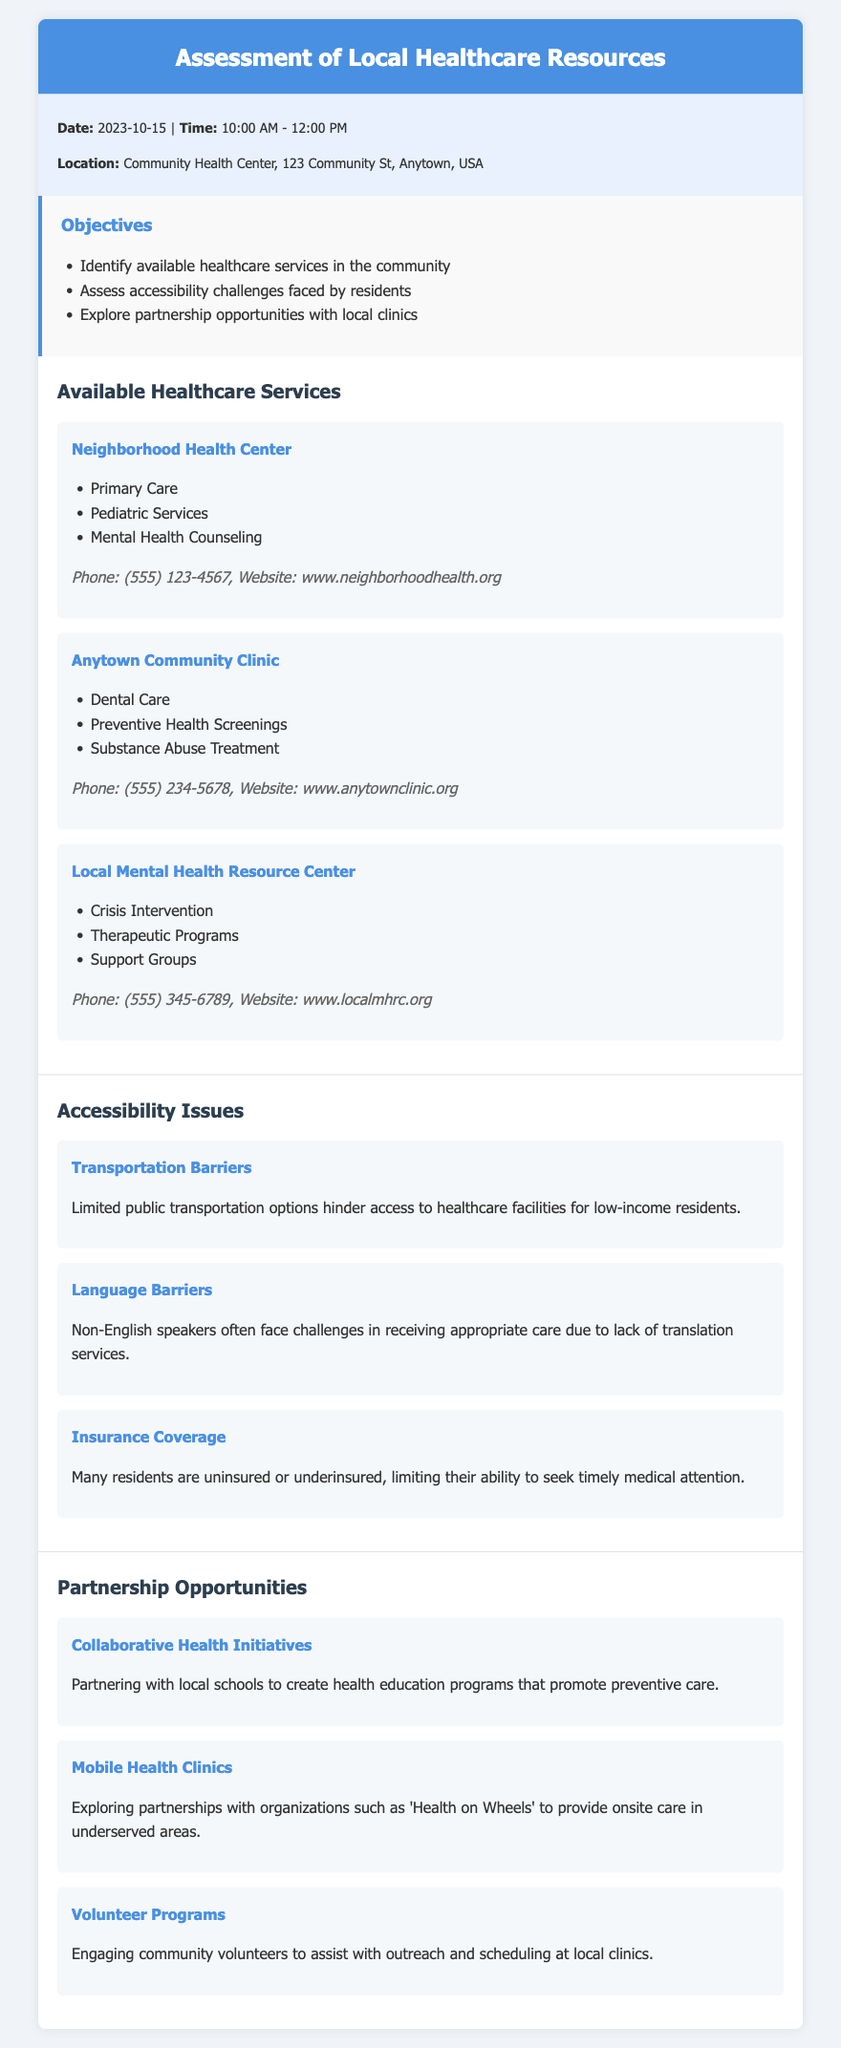What is the date of the assessment? The date of the assessment is mentioned in the meta-info section of the document.
Answer: 2023-10-15 What service does the Neighborhood Health Center provide? The document lists the services provided by the Neighborhood Health Center, one of which is primary care.
Answer: Primary Care Which clinic offers substance abuse treatment? The Anytown Community Clinic provides substance abuse treatment, as noted in the available services section.
Answer: Anytown Community Clinic What is a major accessibility issue faced by residents? The document lists several accessibility issues, and one major issue is transportation barriers.
Answer: Transportation Barriers How can local schools get involved with health initiatives? The document suggests partnering with local schools for health education programs as a collaboration opportunity.
Answer: Health education programs How many clinics are mentioned in the healthcare services section? The section lists three clinics along with their services provided, which can be counted.
Answer: 3 What type of programs is Health on Wheels associated with? The document outlines the opportunity for partnerships and mentions mobile health clinics associated with Health on Wheels.
Answer: Mobile Health Clinics What is the contact number for the Local Mental Health Resource Center? The phone number for the Local Mental Health Resource Center is provided in the contact information section.
Answer: (555) 345-6789 What language barrier issue is mentioned? The document discusses challenges non-English speakers face in receiving care due to a specific lack of service.
Answer: Lack of translation services 